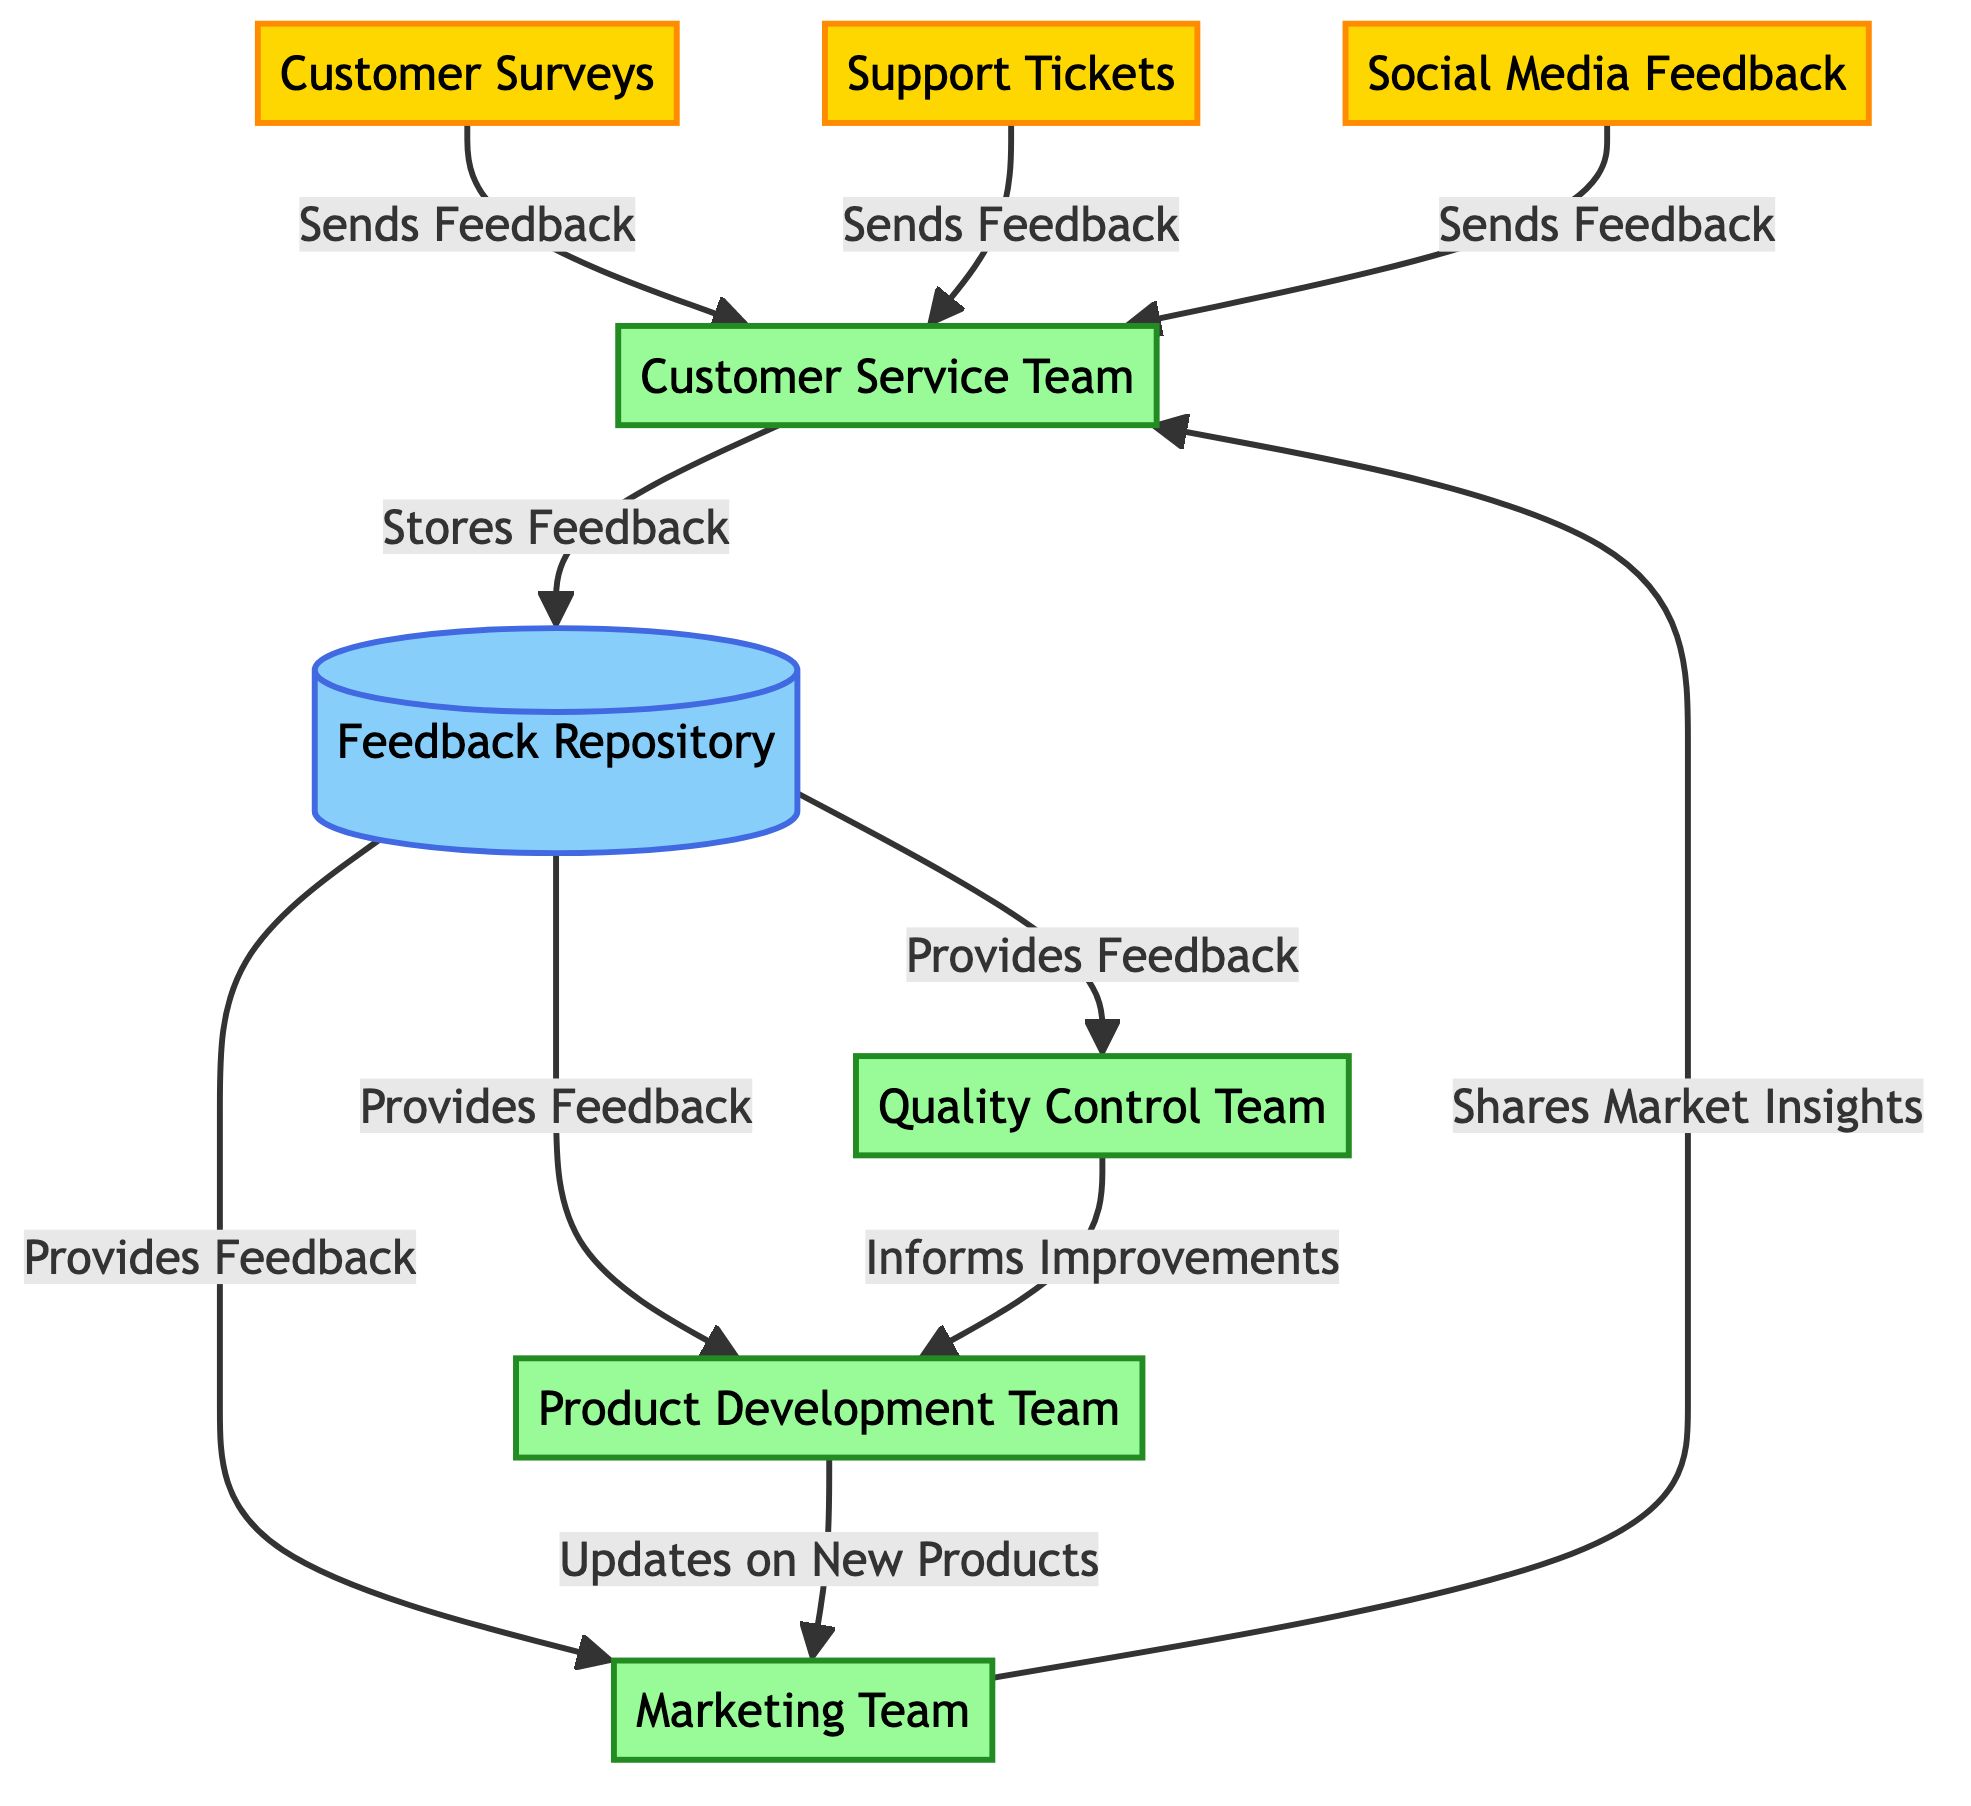What are the three feedback sources in the diagram? The diagram includes Customer Surveys, Support Tickets, and Social Media Feedback as the feedback sources.
Answer: Customer Surveys, Support Tickets, Social Media Feedback How many processing units are in the diagram? The diagram shows four processing units: Customer Service Team, Quality Control Team, Product Development Team, and Marketing Team. Counting those gives a total of four processing units.
Answer: 4 What is the relationship between the Customer Service Team and the Feedback Repository? The relationship is defined as "Stores Feedback," meaning the Customer Service Team sends collected feedback to the Feedback Repository for storage.
Answer: Stores Feedback Which team informs improvements to the Product Development Team? The Quality Control Team informs improvements to the Product Development Team, as indicated in the diagram.
Answer: Quality Control Team What does the Marketing Team share with the Customer Service Team? The Marketing Team shares market insights with the Customer Service Team, as specified in the diagram.
Answer: Market Insights Which node provides feedback to the Quality Control Team? The Feedback Repository provides feedback to the Quality Control Team, facilitating quality improvements based on received customer feedback.
Answer: Feedback Repository How many links are there between nodes in this diagram? There are a total of eight links, representing the relationships between the nodes in the network diagram.
Answer: 8 Which team receives feedback from Support Tickets? The Customer Service Team receives feedback from Support Tickets, as shown in the diagram.
Answer: Customer Service Team What kind of feedback does the Product Development Team receive from the Feedback Repository? The Product Development Team receives feedback from the Feedback Repository, specifically for use in product development initiatives.
Answer: Provides Feedback 